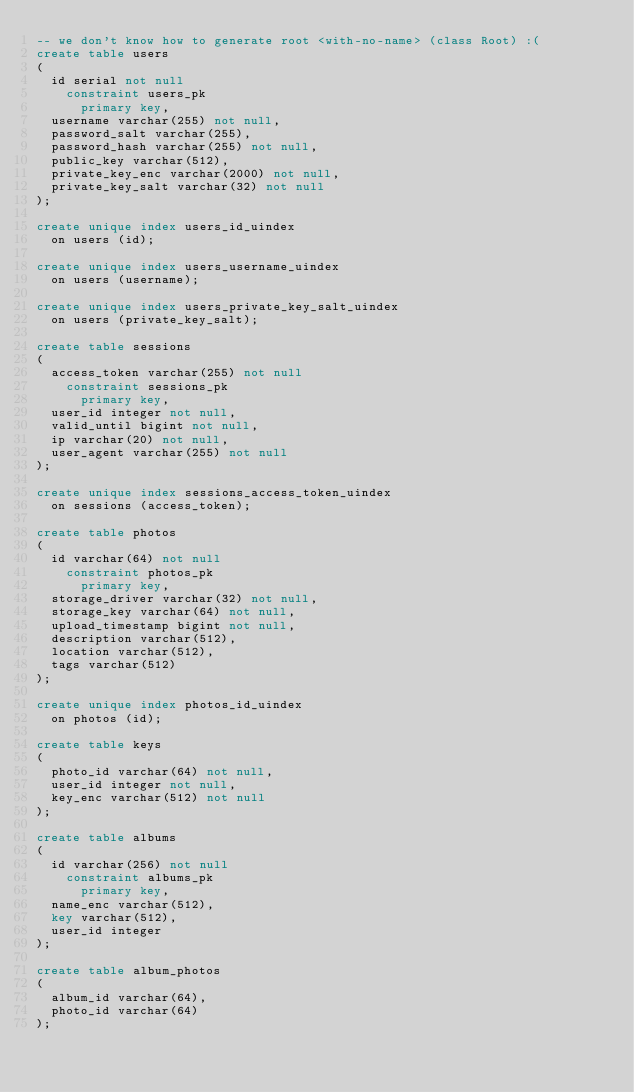Convert code to text. <code><loc_0><loc_0><loc_500><loc_500><_SQL_>-- we don't know how to generate root <with-no-name> (class Root) :(
create table users
(
	id serial not null
		constraint users_pk
			primary key,
	username varchar(255) not null,
	password_salt varchar(255),
	password_hash varchar(255) not null,
	public_key varchar(512),
	private_key_enc varchar(2000) not null,
	private_key_salt varchar(32) not null
);

create unique index users_id_uindex
	on users (id);

create unique index users_username_uindex
	on users (username);

create unique index users_private_key_salt_uindex
	on users (private_key_salt);

create table sessions
(
	access_token varchar(255) not null
		constraint sessions_pk
			primary key,
	user_id integer not null,
	valid_until bigint not null,
	ip varchar(20) not null,
	user_agent varchar(255) not null
);

create unique index sessions_access_token_uindex
	on sessions (access_token);

create table photos
(
	id varchar(64) not null
		constraint photos_pk
			primary key,
	storage_driver varchar(32) not null,
	storage_key varchar(64) not null,
	upload_timestamp bigint not null,
	description varchar(512),
	location varchar(512),
	tags varchar(512)
);

create unique index photos_id_uindex
	on photos (id);

create table keys
(
	photo_id varchar(64) not null,
	user_id integer not null,
	key_enc varchar(512) not null
);

create table albums
(
	id varchar(256) not null
		constraint albums_pk
			primary key,
	name_enc varchar(512),
	key varchar(512),
	user_id integer
);

create table album_photos
(
	album_id varchar(64),
	photo_id varchar(64)
);
</code> 